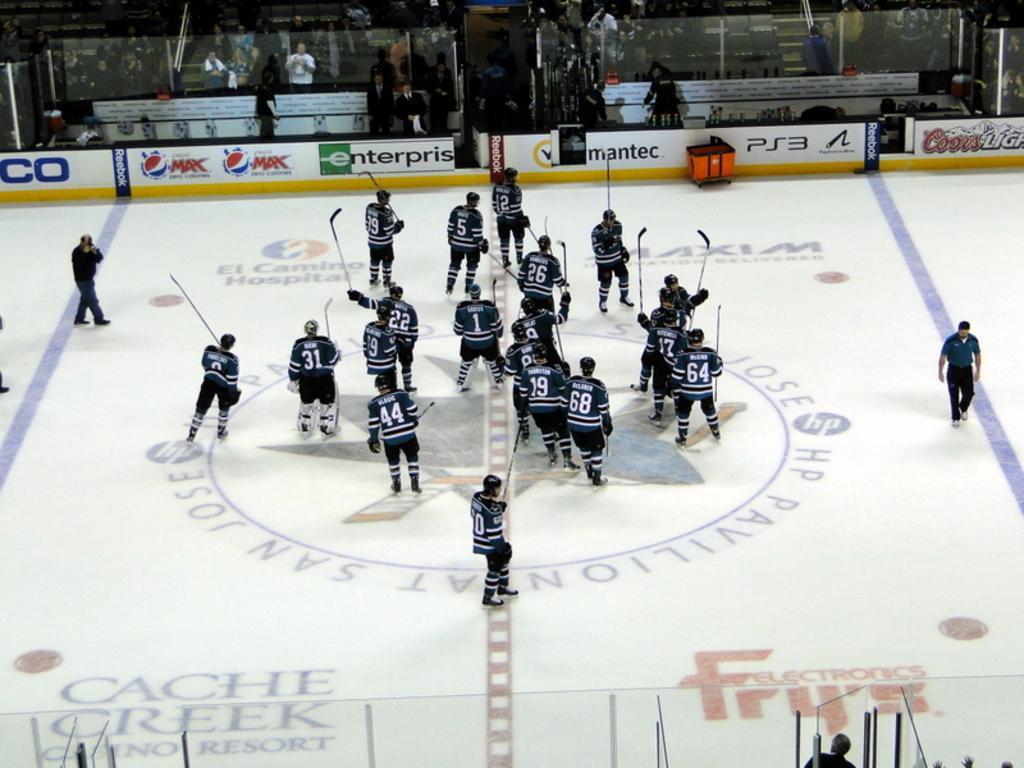Could you give a brief overview of what you see in this image? In the background we can see the people, hoardings, glass walls and few other objects. In this picture we can see the people holding sticks in their hands and they are on the floor. It seems like they are doing ice skating. We can see other people walking. At the bottom portion of the picture we can see the glass, a person and person hands. 